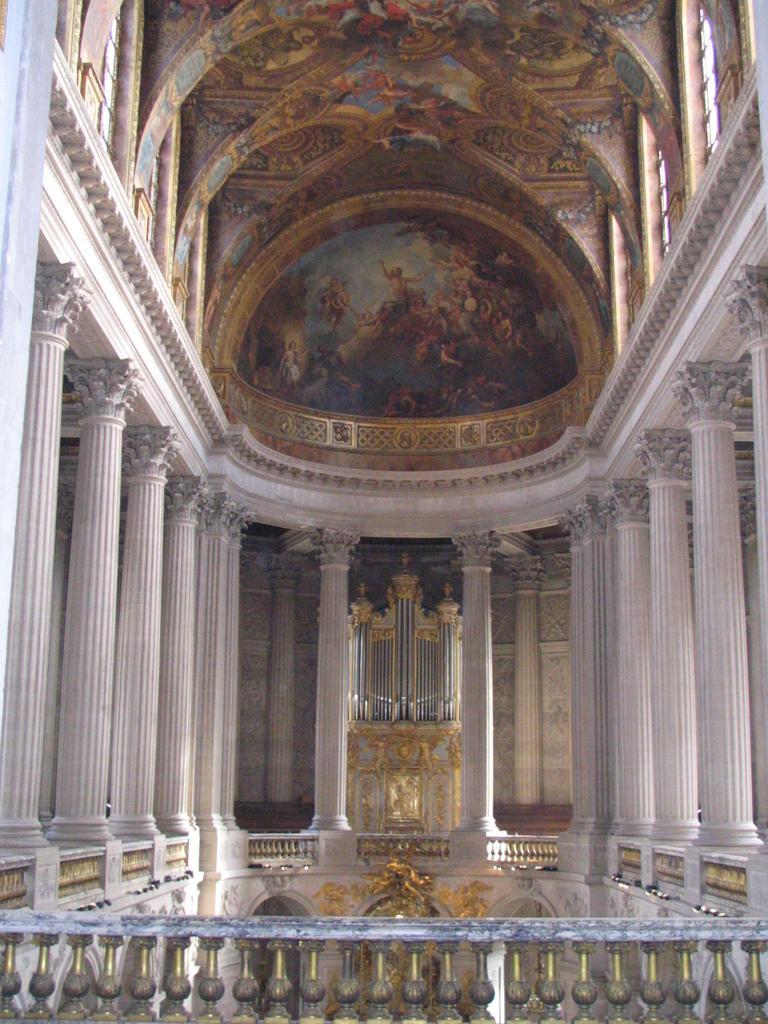In one or two sentences, can you explain what this image depicts? This is the inside view of a building. On the sides there are pillars. On the ceiling there are paintings. In the front there is a railing. 